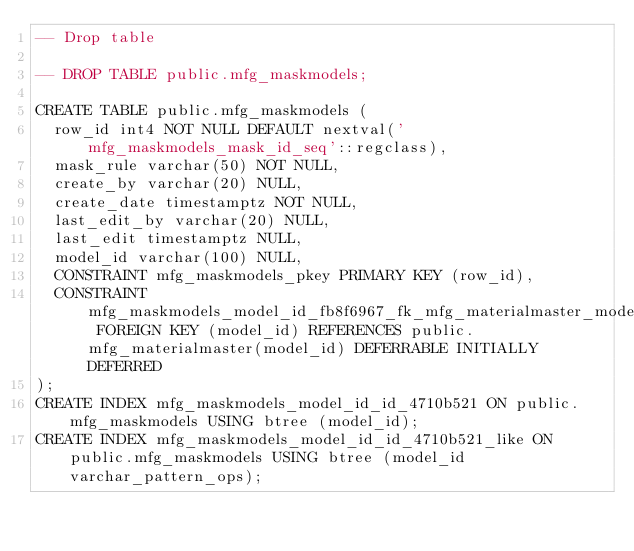Convert code to text. <code><loc_0><loc_0><loc_500><loc_500><_SQL_>-- Drop table

-- DROP TABLE public.mfg_maskmodels;

CREATE TABLE public.mfg_maskmodels (
	row_id int4 NOT NULL DEFAULT nextval('mfg_maskmodels_mask_id_seq'::regclass),
	mask_rule varchar(50) NOT NULL,
	create_by varchar(20) NULL,
	create_date timestamptz NOT NULL,
	last_edit_by varchar(20) NULL,
	last_edit timestamptz NULL,
	model_id varchar(100) NULL,
	CONSTRAINT mfg_maskmodels_pkey PRIMARY KEY (row_id),
	CONSTRAINT mfg_maskmodels_model_id_fb8f6967_fk_mfg_materialmaster_model_id FOREIGN KEY (model_id) REFERENCES public.mfg_materialmaster(model_id) DEFERRABLE INITIALLY DEFERRED
);
CREATE INDEX mfg_maskmodels_model_id_id_4710b521 ON public.mfg_maskmodels USING btree (model_id);
CREATE INDEX mfg_maskmodels_model_id_id_4710b521_like ON public.mfg_maskmodels USING btree (model_id varchar_pattern_ops);
</code> 